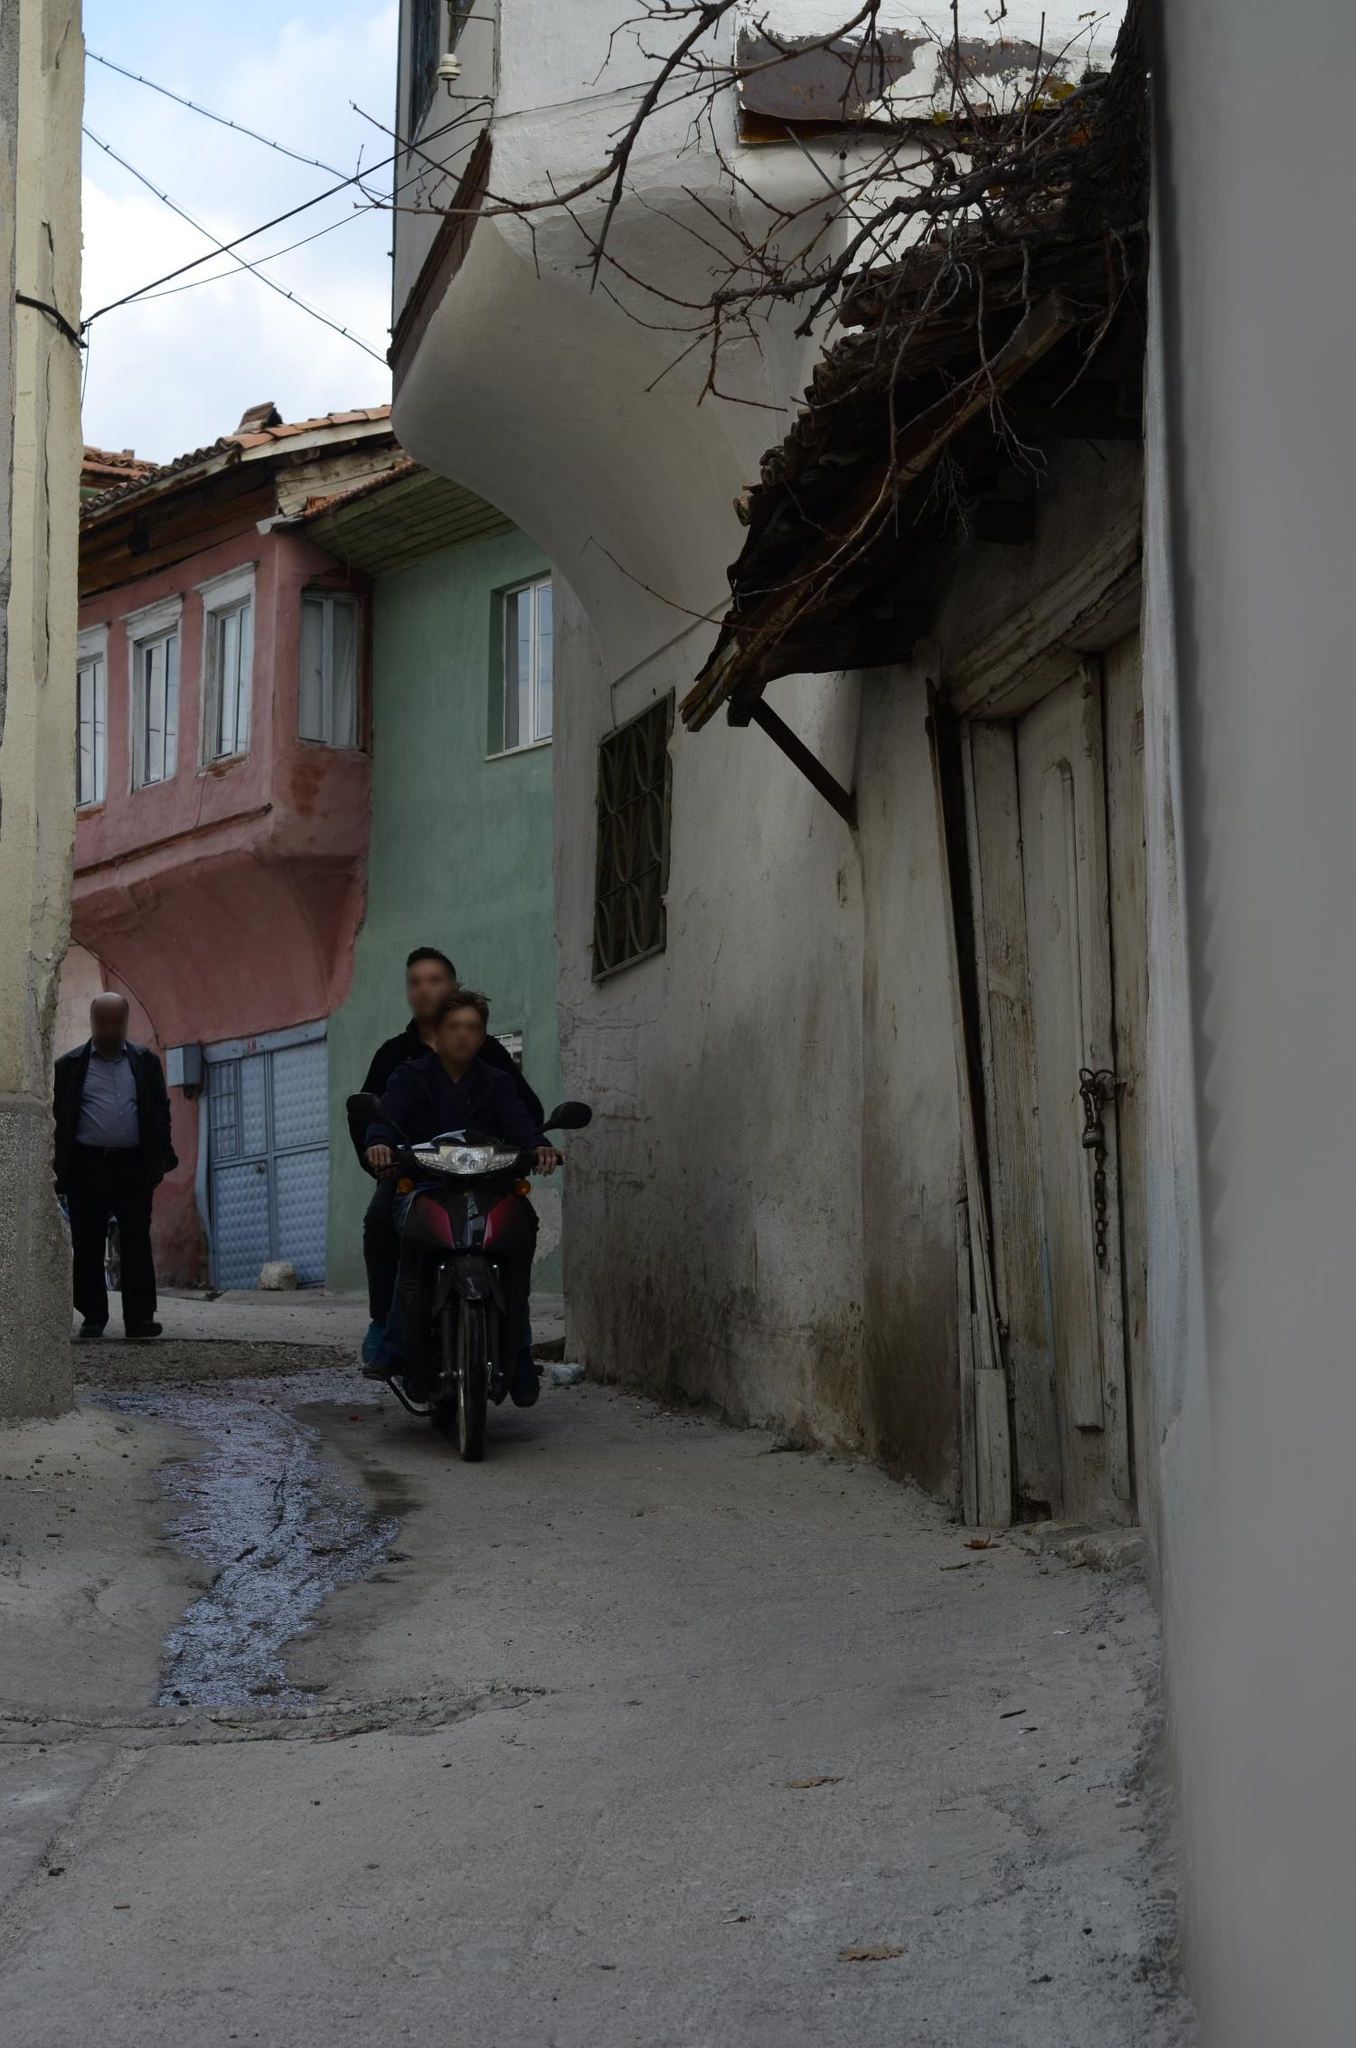What does the presence of a motorcycle and a pedestrian tell us about this location? The presence of both a motorcycle and a pedestrian in the narrow alley suggests it's a shared space integral to the locality’s daily activities. This setup indicates the street is a key thoroughfare, despite its narrow width, showcasing how residents adapt their transportation needs to the available infrastructure. The motorcycle's ability to navigate such a confined space hints at the practicality and necessity of such vehicles in this setting, while the pedestrian's relaxed pace may signify a close proximity to essential destinations, such as markets, cafes, or meeting points, emphasizing a community-oriented lifestyle. 